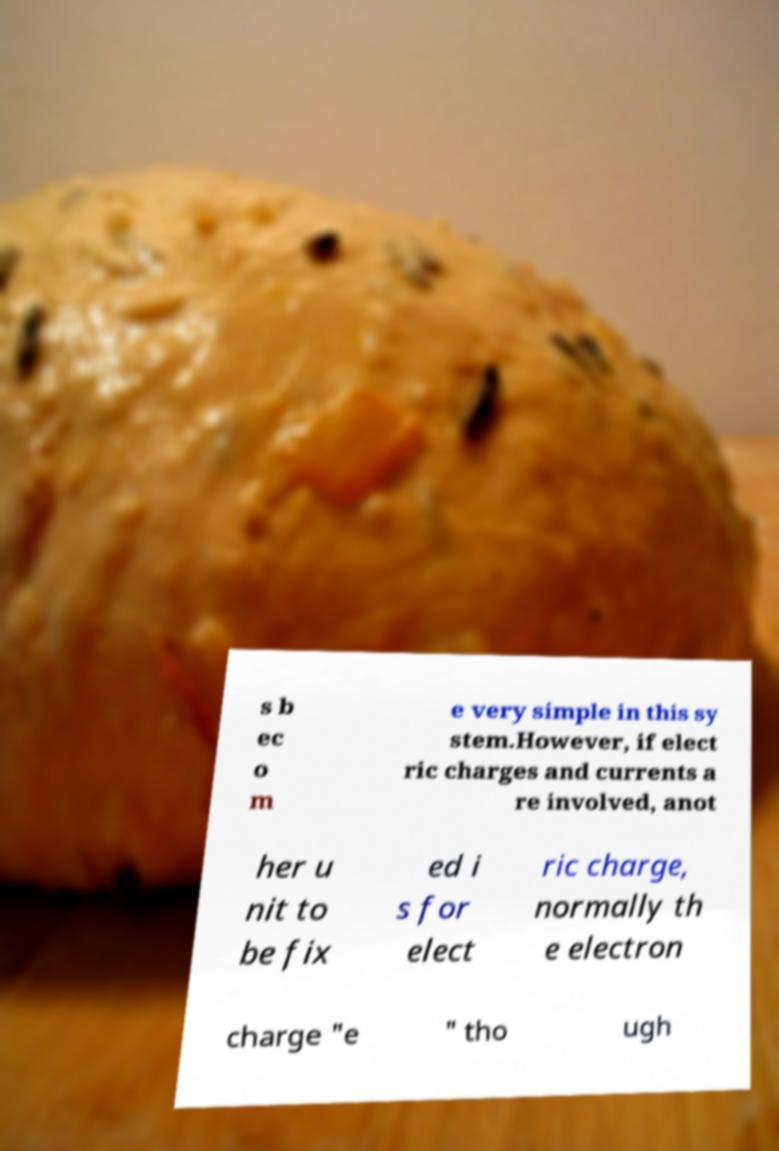Could you assist in decoding the text presented in this image and type it out clearly? s b ec o m e very simple in this sy stem.However, if elect ric charges and currents a re involved, anot her u nit to be fix ed i s for elect ric charge, normally th e electron charge "e " tho ugh 